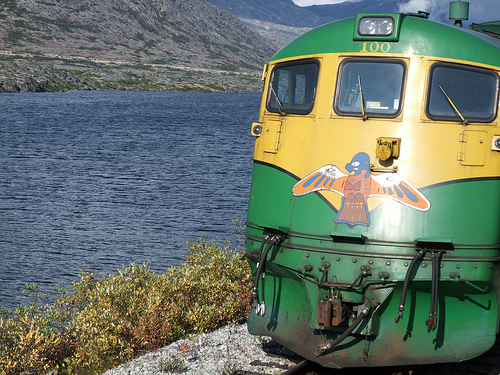<image>
Is there a train to the right of the water? Yes. From this viewpoint, the train is positioned to the right side relative to the water. Is the ocean in front of the train? No. The ocean is not in front of the train. The spatial positioning shows a different relationship between these objects. 